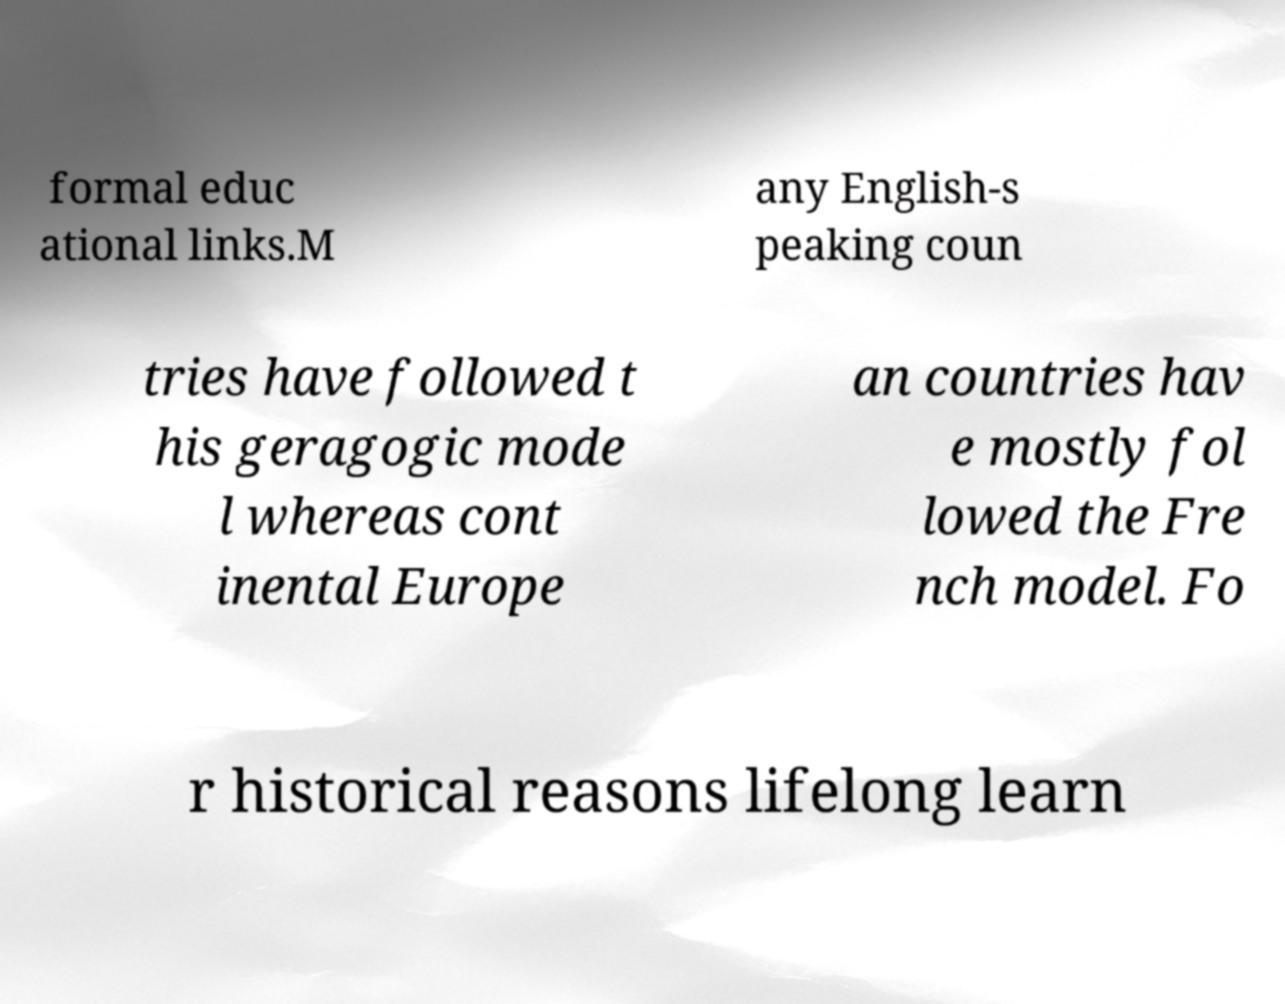For documentation purposes, I need the text within this image transcribed. Could you provide that? formal educ ational links.M any English-s peaking coun tries have followed t his geragogic mode l whereas cont inental Europe an countries hav e mostly fol lowed the Fre nch model. Fo r historical reasons lifelong learn 